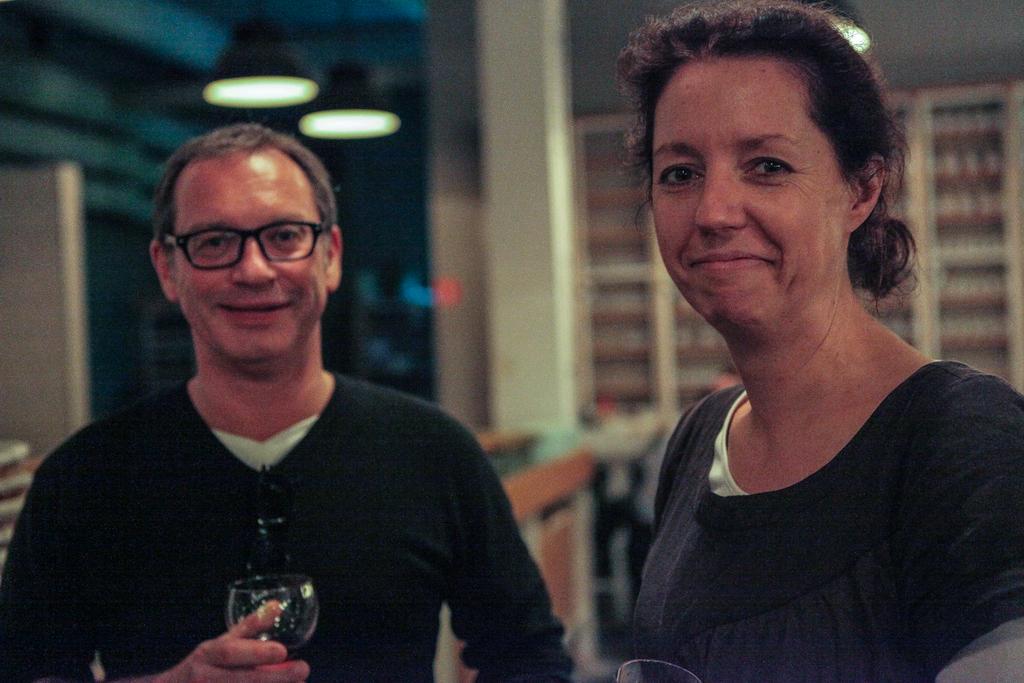Can you describe this image briefly? In this image we can see two persons. The man is holding a glass and at the back ground we can racks and a light. 